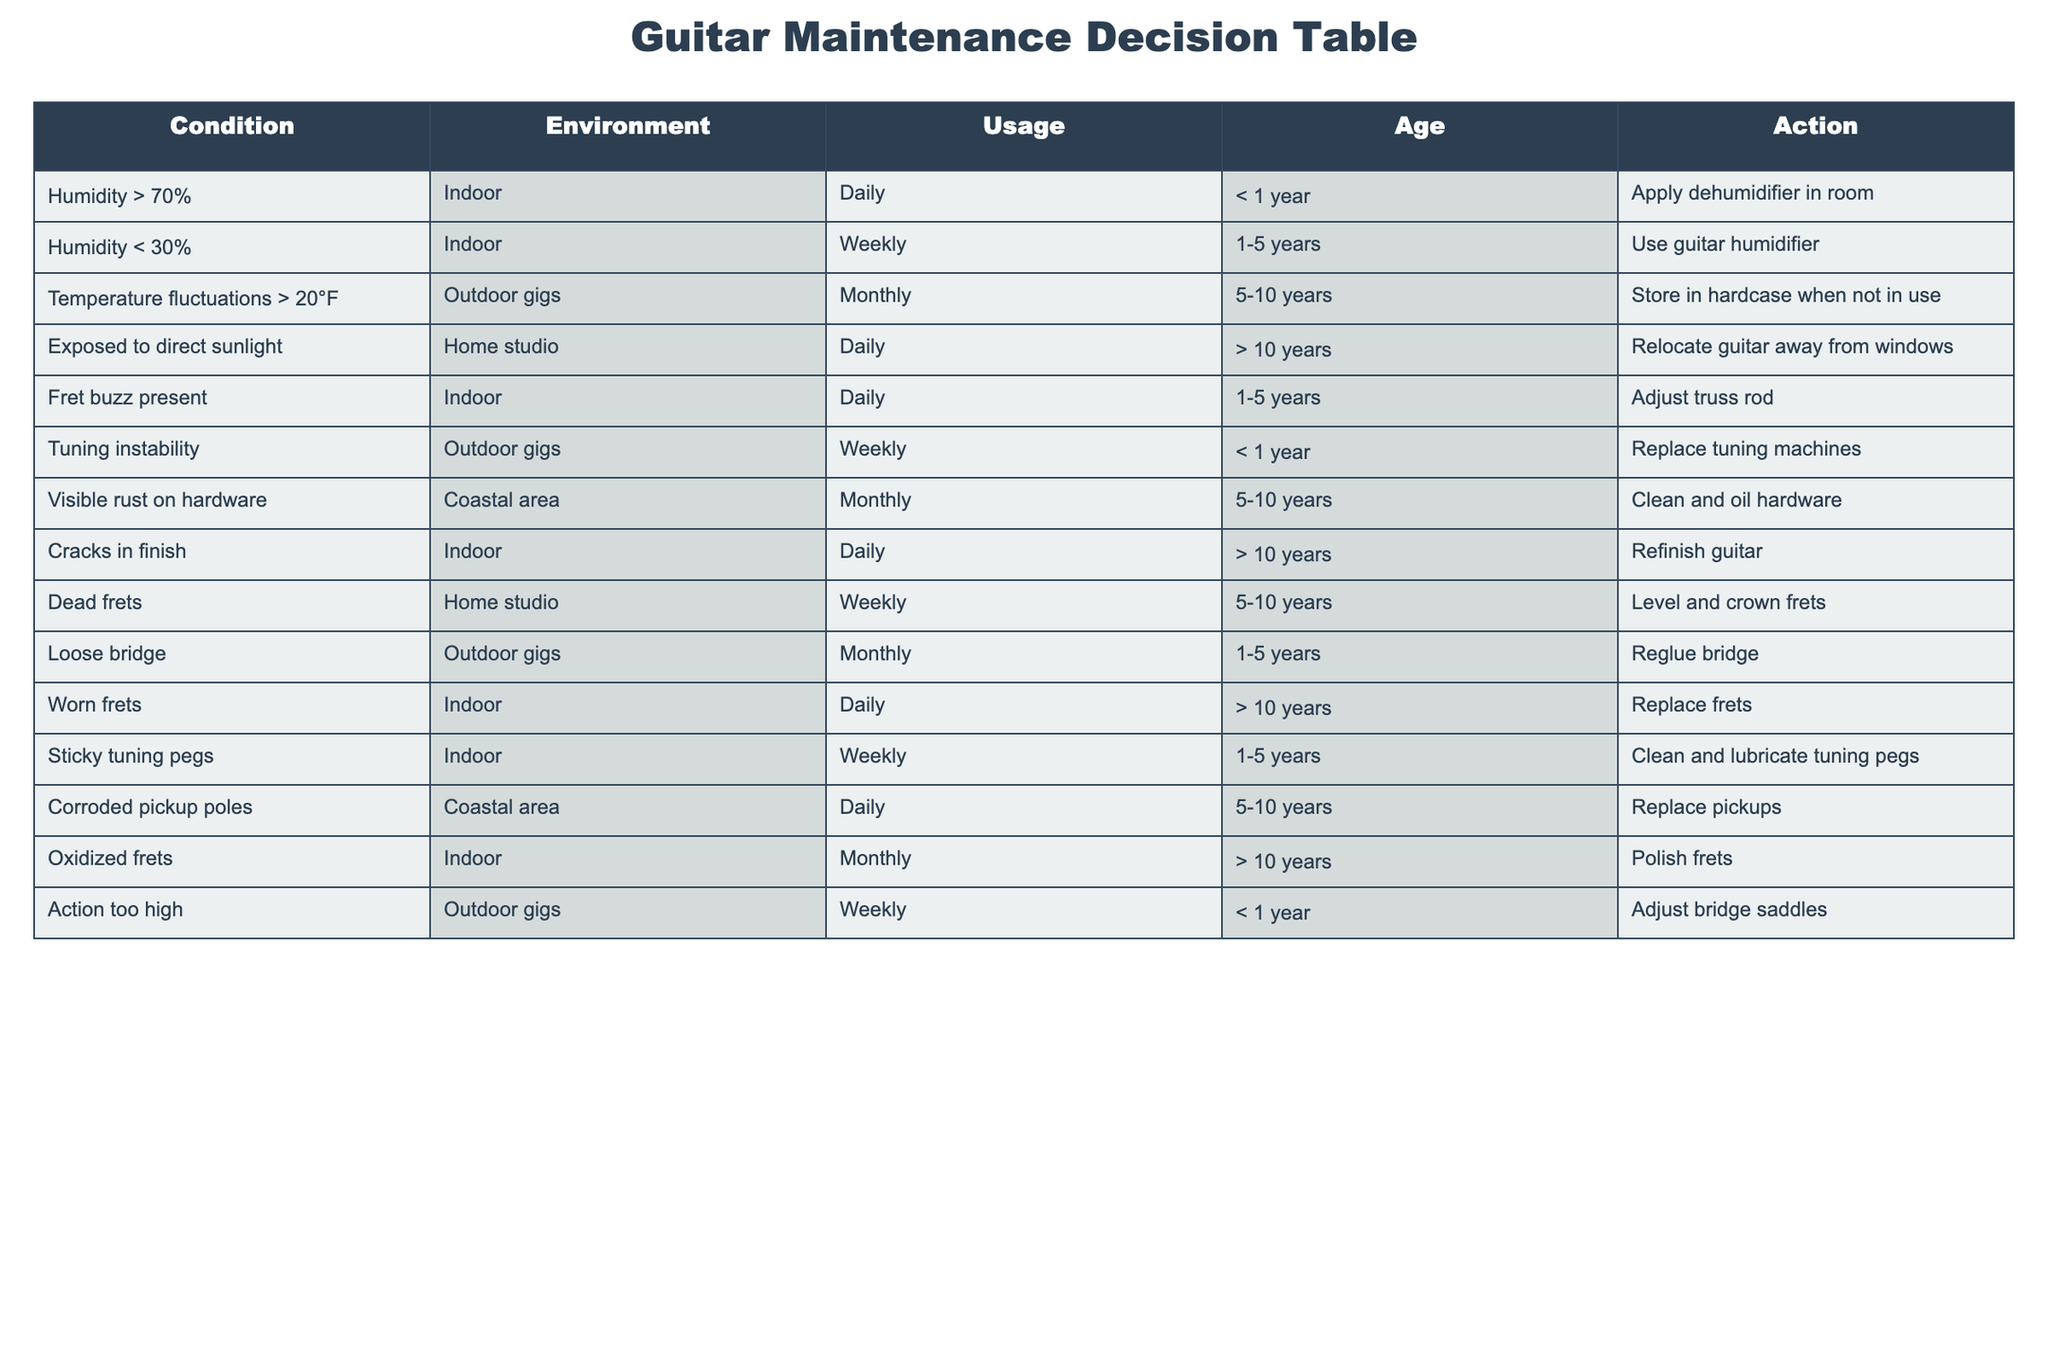What's the recommended action if the humidity is greater than 70%? According to the table, if the humidity is greater than 70%, the action suggested is to apply a dehumidifier in the room.
Answer: Apply dehumidifier in room What should I do if I notice fret buzz present on a guitar that is used daily and is 1-5 years old? The table indicates that if fret buzz is present, the recommended action is to adjust the truss rod for a guitar with daily usage aged 1-5 years.
Answer: Adjust truss rod How many actions are recommended for guitars exposed to direct sunlight for more than 10 years? The table lists one action for guitars over 10 years exposed to direct sunlight, which is to relocate the guitar away from windows.
Answer: One action Is it necessary to clean and lubricate tuning pegs weekly for guitars that are between 1-5 years old in indoor environments? Yes, the table states that for indoor guitars used weekly and aged 1-5 years, it is necessary to clean and lubricate the tuning pegs.
Answer: Yes What is the action taken for a loose bridge on a guitar that is used in outdoor gigs and is 1-5 years old? According to the table, if there is a loose bridge on a guitar used in outdoor gigs aged 1-5 years, the action is to reglue the bridge.
Answer: Reglue bridge How many conditions result in a monthly maintenance action? Reviewing the table shows that there are four conditions resulting in a monthly action: temperature fluctuations, visible rust on hardware, dead frets, and oxidized frets. Summing these gives a total of four monthly actions.
Answer: Four conditions If the guitar has tuning instability and is less than a year old, what action should be taken? The table suggests replacing the tuning machines for a guitar that exhibits tuning instability and is less than a year old.
Answer: Replace tuning machines For guitars that have visible rust on hardware and are from a coastal area, what is the recommended action regardless of usage frequency? The recommended action for guitars with visible rust in a coastal area is to clean and oil the hardware, as indicated in the table, which applies regardless of usage frequency.
Answer: Clean and oil hardware If a guitar is getting exposed to direct sunlight daily for over 10 years, what should be the action taken? The table specifies that the action for a guitar exposed to direct sunlight for more than 10 years is to relocate it away from windows, indicating the importance of protecting the finish and components from sun damage.
Answer: Relocate guitar away from windows 